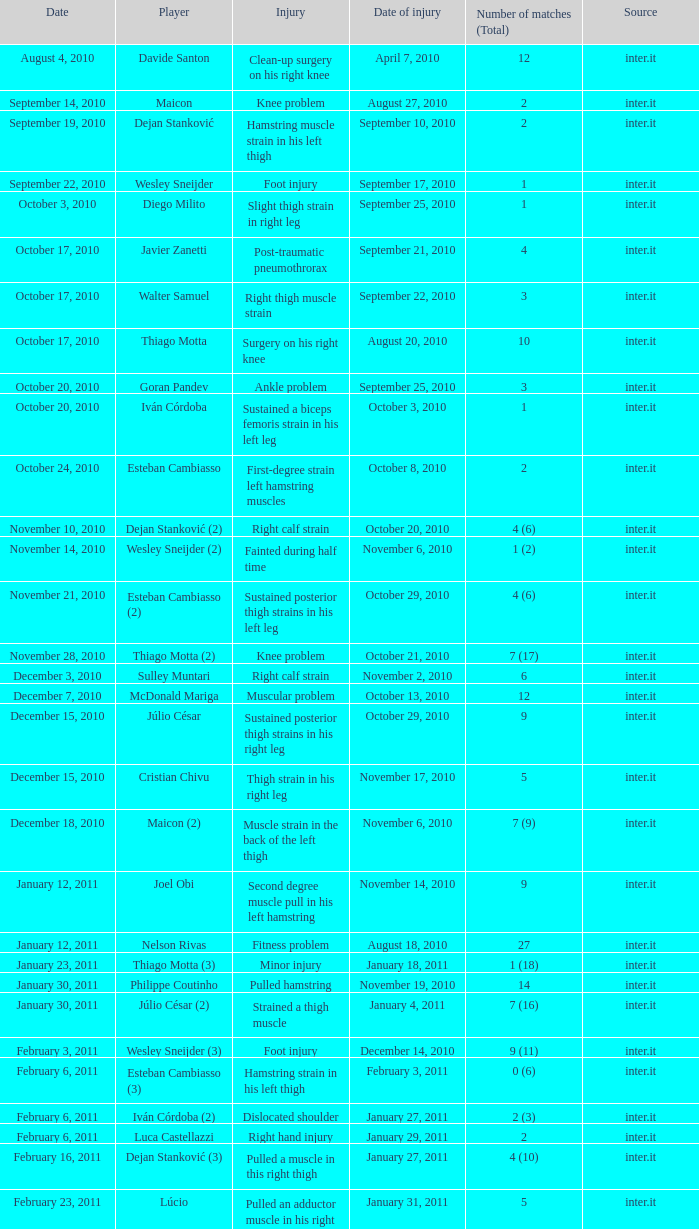What is the injury date for a foot injury when there is only 1 match in total? September 17, 2010. 